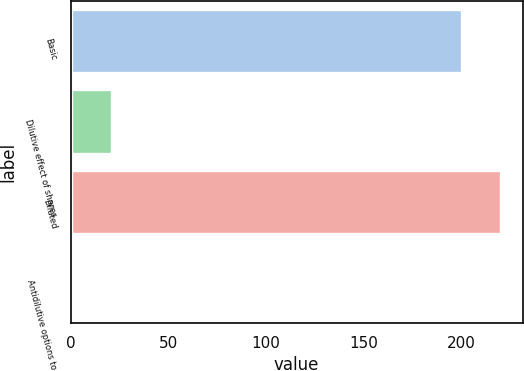<chart> <loc_0><loc_0><loc_500><loc_500><bar_chart><fcel>Basic<fcel>Dilutive effect of shares<fcel>Diluted<fcel>Antidilutive options to<nl><fcel>200.1<fcel>20.97<fcel>220.37<fcel>0.7<nl></chart> 